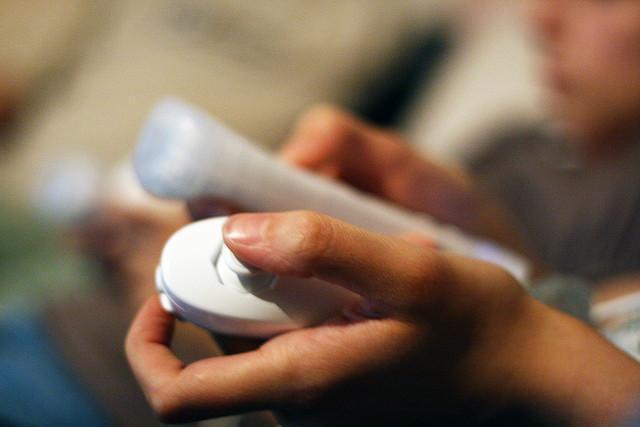How many people can you see?
Give a very brief answer. 2. How many remotes can you see?
Give a very brief answer. 2. How many colors on the umbrella do you see?
Give a very brief answer. 0. 